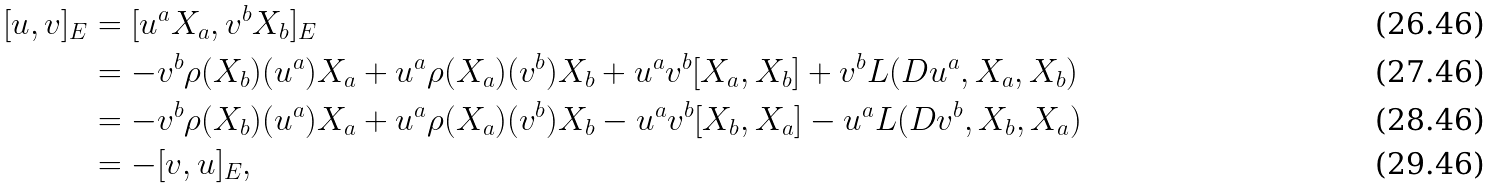Convert formula to latex. <formula><loc_0><loc_0><loc_500><loc_500>[ u , v ] _ { E } & = [ u ^ { a } X _ { a } , v ^ { b } X _ { b } ] _ { E } \\ & = - v ^ { b } \rho ( X _ { b } ) ( u ^ { a } ) X _ { a } + u ^ { a } \rho ( X _ { a } ) ( v ^ { b } ) X _ { b } + u ^ { a } v ^ { b } [ X _ { a } , X _ { b } ] + v ^ { b } L ( D u ^ { a } , X _ { a } , X _ { b } ) \\ & = - v ^ { b } \rho ( X _ { b } ) ( u ^ { a } ) X _ { a } + u ^ { a } \rho ( X _ { a } ) ( v ^ { b } ) X _ { b } - u ^ { a } v ^ { b } [ X _ { b } , X _ { a } ] - u ^ { a } L ( D v ^ { b } , X _ { b } , X _ { a } ) \\ & = - [ v , u ] _ { E } ,</formula> 